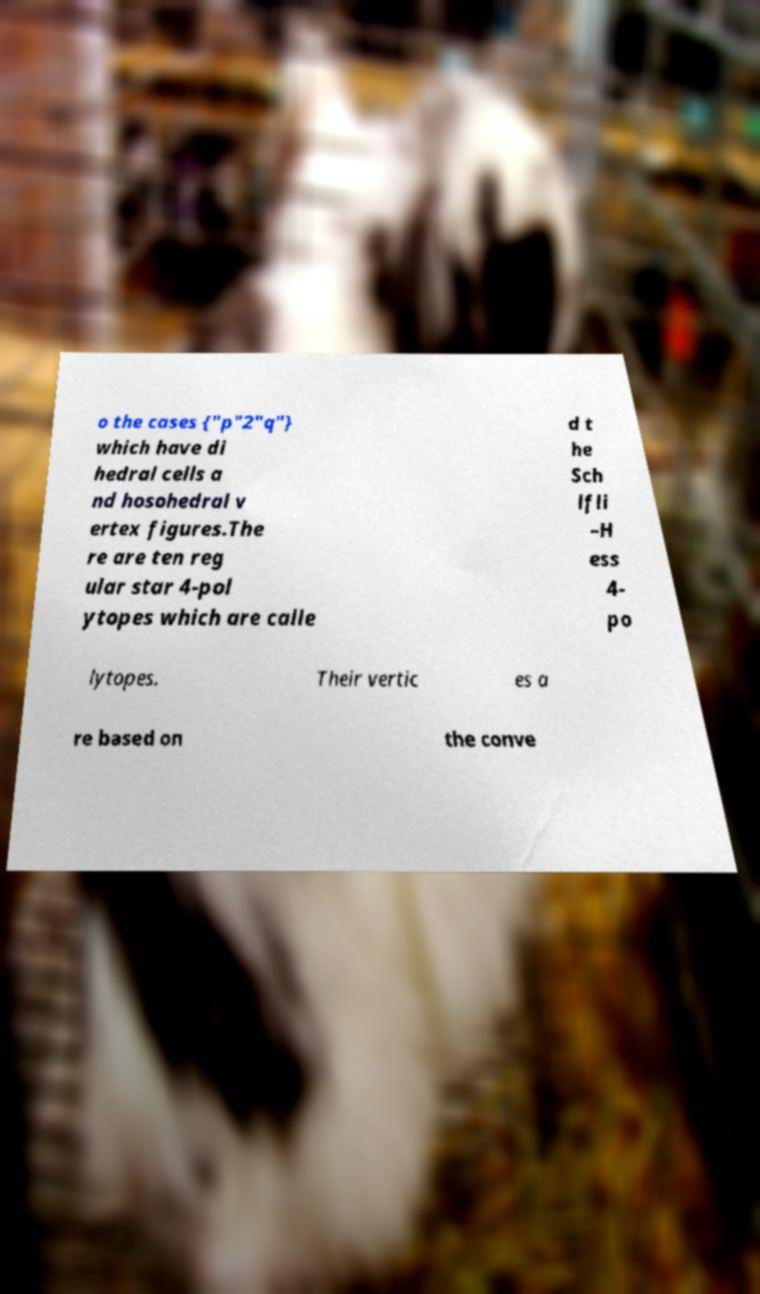Can you read and provide the text displayed in the image?This photo seems to have some interesting text. Can you extract and type it out for me? o the cases {"p"2"q"} which have di hedral cells a nd hosohedral v ertex figures.The re are ten reg ular star 4-pol ytopes which are calle d t he Sch lfli –H ess 4- po lytopes. Their vertic es a re based on the conve 